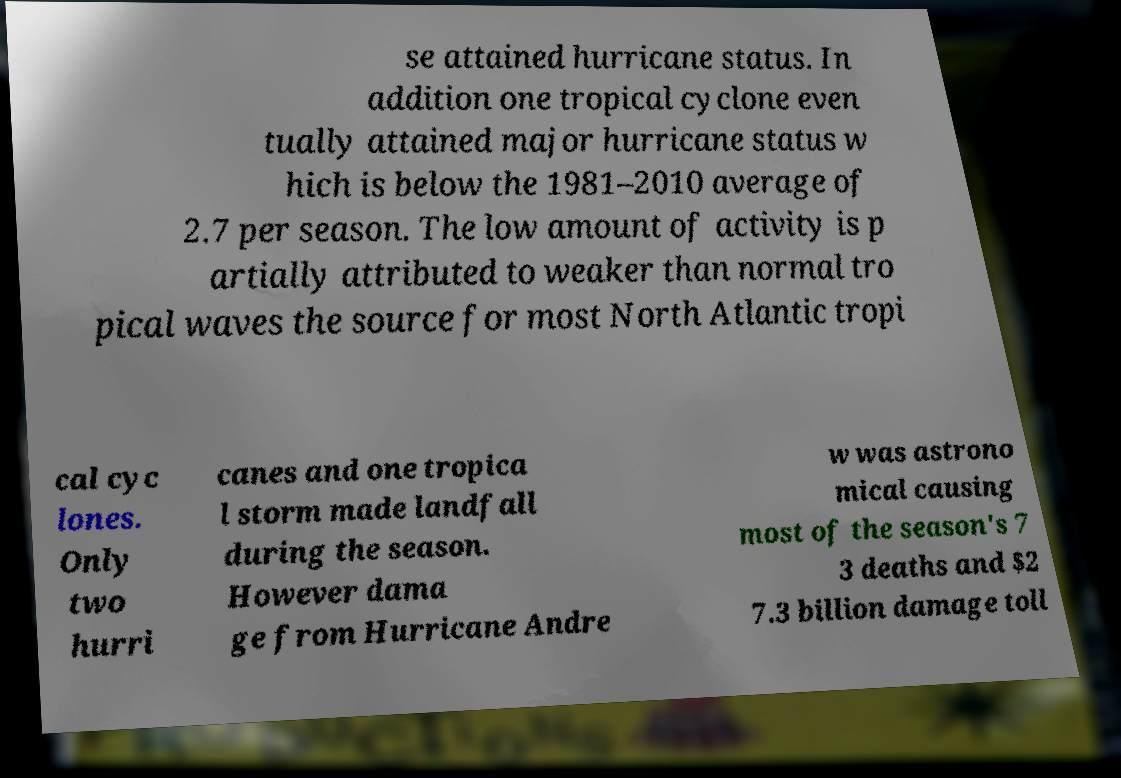Could you assist in decoding the text presented in this image and type it out clearly? se attained hurricane status. In addition one tropical cyclone even tually attained major hurricane status w hich is below the 1981–2010 average of 2.7 per season. The low amount of activity is p artially attributed to weaker than normal tro pical waves the source for most North Atlantic tropi cal cyc lones. Only two hurri canes and one tropica l storm made landfall during the season. However dama ge from Hurricane Andre w was astrono mical causing most of the season's 7 3 deaths and $2 7.3 billion damage toll 